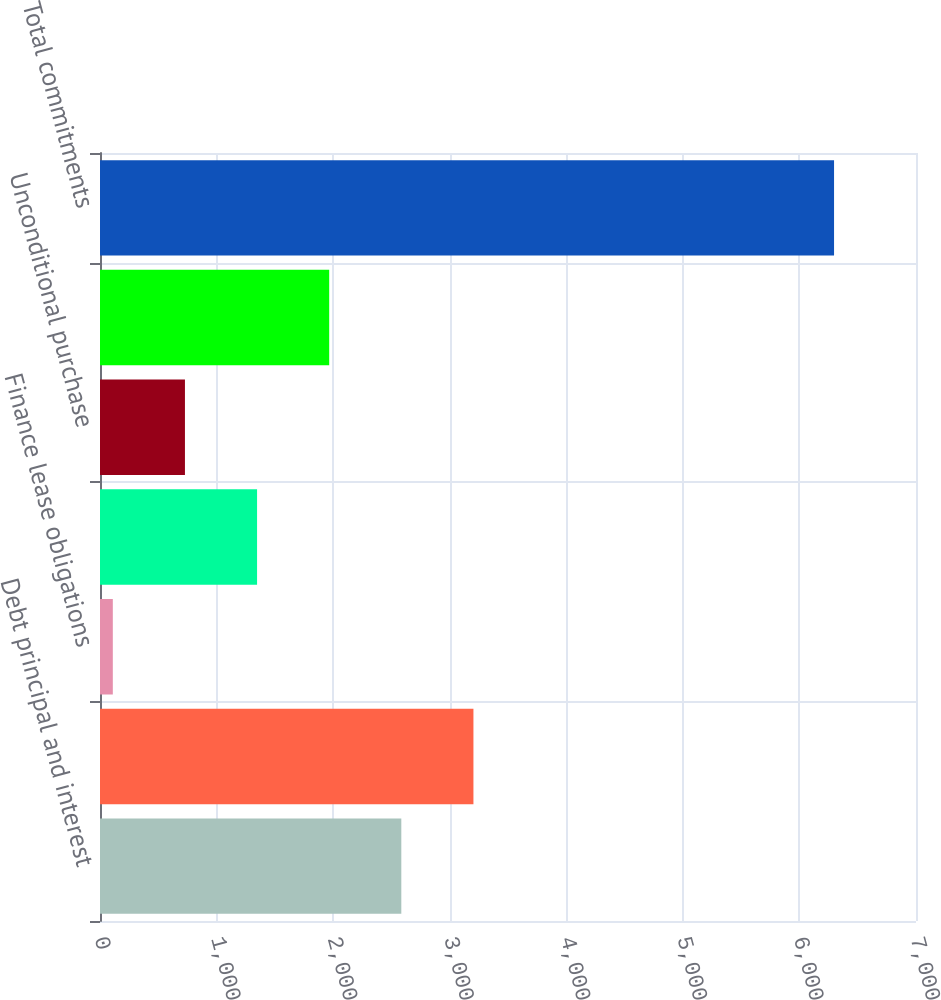Convert chart. <chart><loc_0><loc_0><loc_500><loc_500><bar_chart><fcel>Debt principal and interest<fcel>Capital leases including<fcel>Finance lease obligations<fcel>Operating leases<fcel>Unconditional purchase<fcel>Other commitments (2) (3)<fcel>Total commitments<nl><fcel>2584.8<fcel>3203.5<fcel>110<fcel>1347.4<fcel>728.7<fcel>1966.1<fcel>6297<nl></chart> 